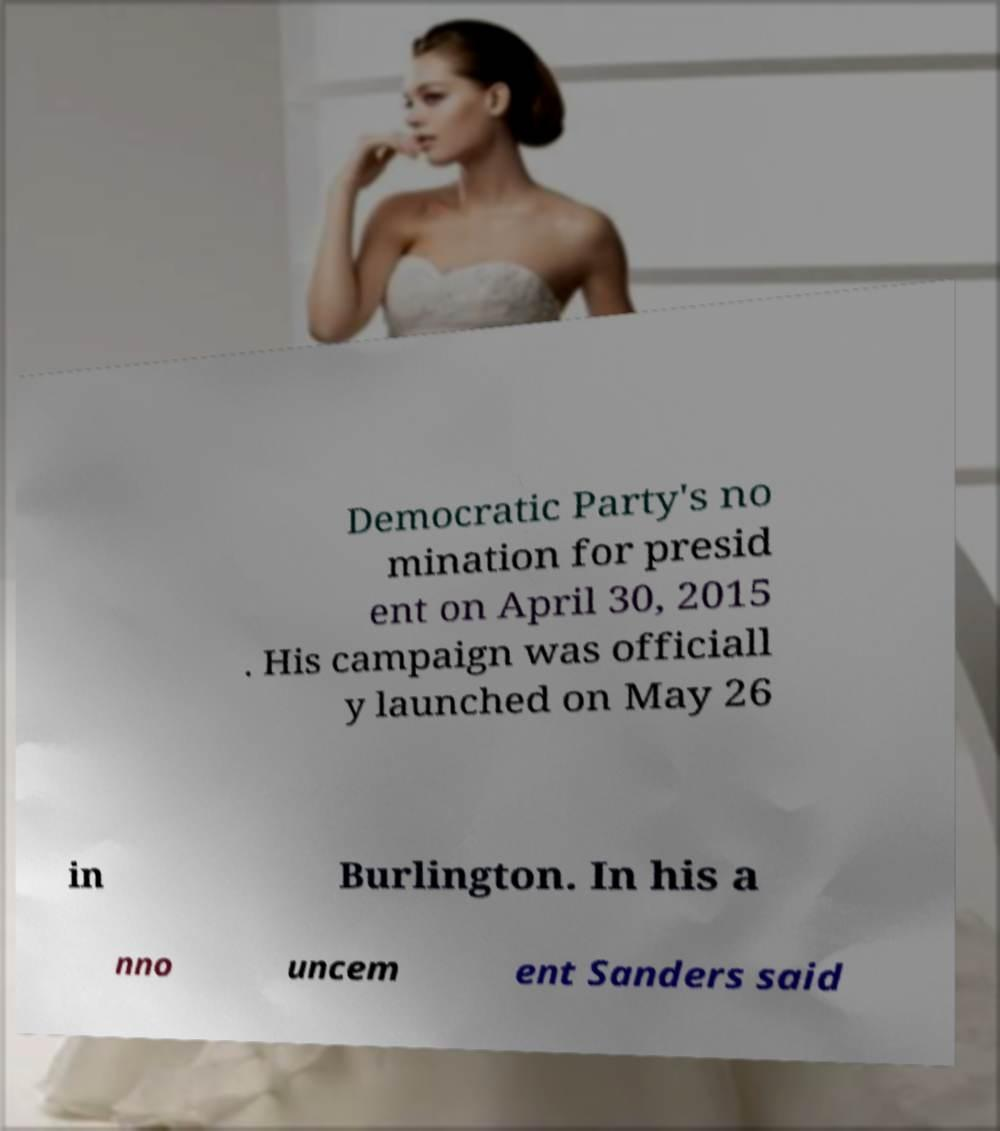Can you read and provide the text displayed in the image?This photo seems to have some interesting text. Can you extract and type it out for me? Democratic Party's no mination for presid ent on April 30, 2015 . His campaign was officiall y launched on May 26 in Burlington. In his a nno uncem ent Sanders said 